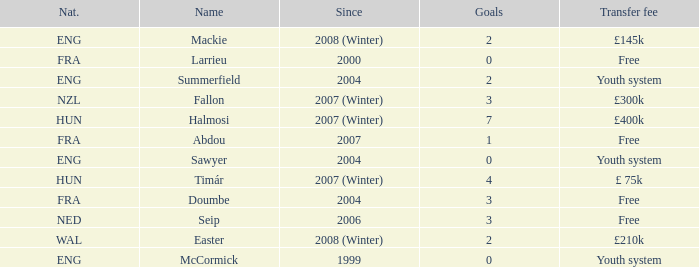What is the nationality of the player with a transfer fee of £400k? HUN. 